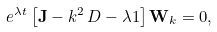Convert formula to latex. <formula><loc_0><loc_0><loc_500><loc_500>e ^ { \lambda t } \left [ \mathbf J - k ^ { 2 } \, D - \lambda 1 \right ] \mathbf W _ { k } = 0 ,</formula> 